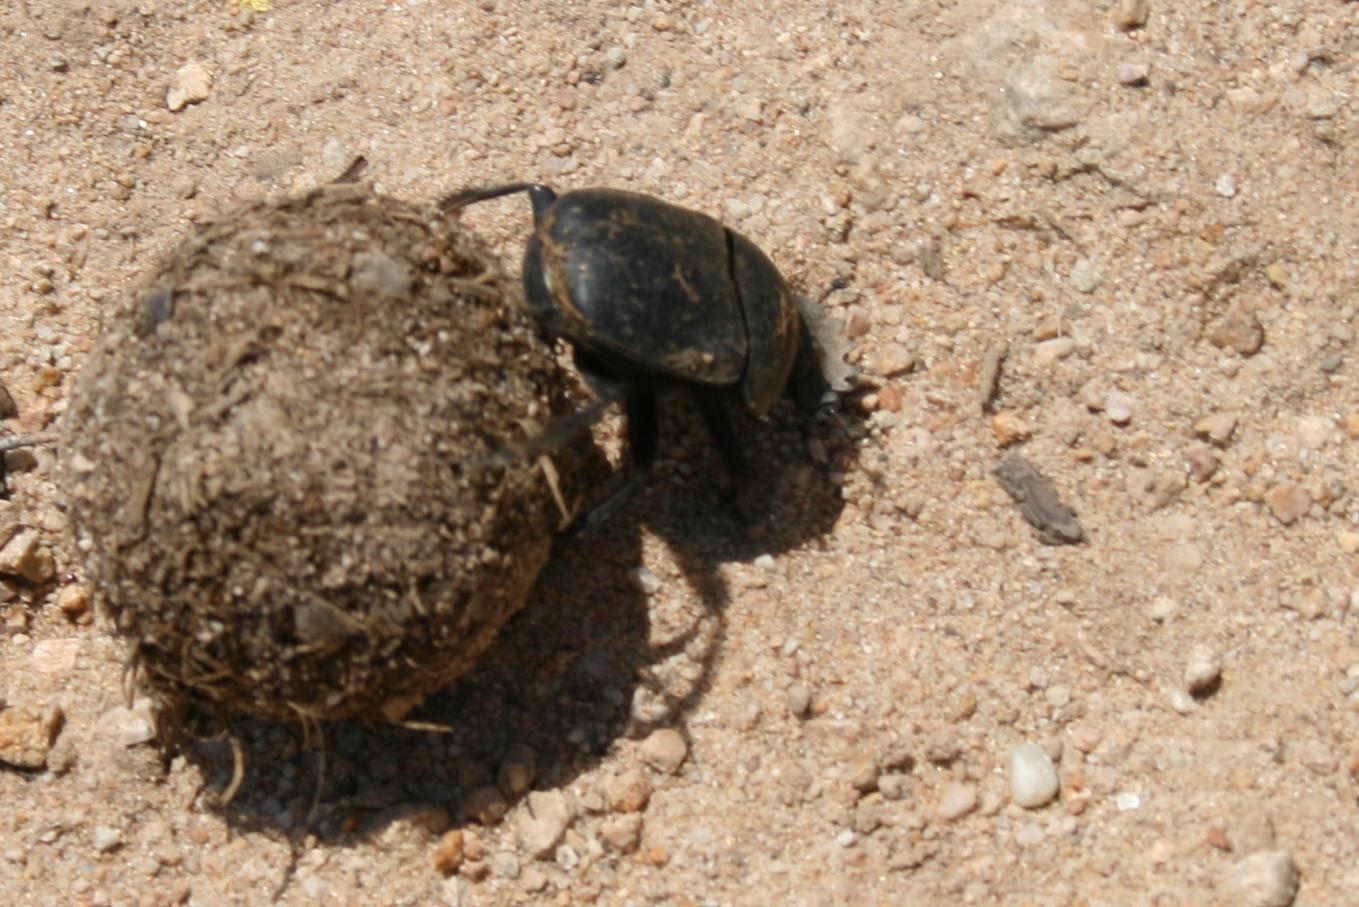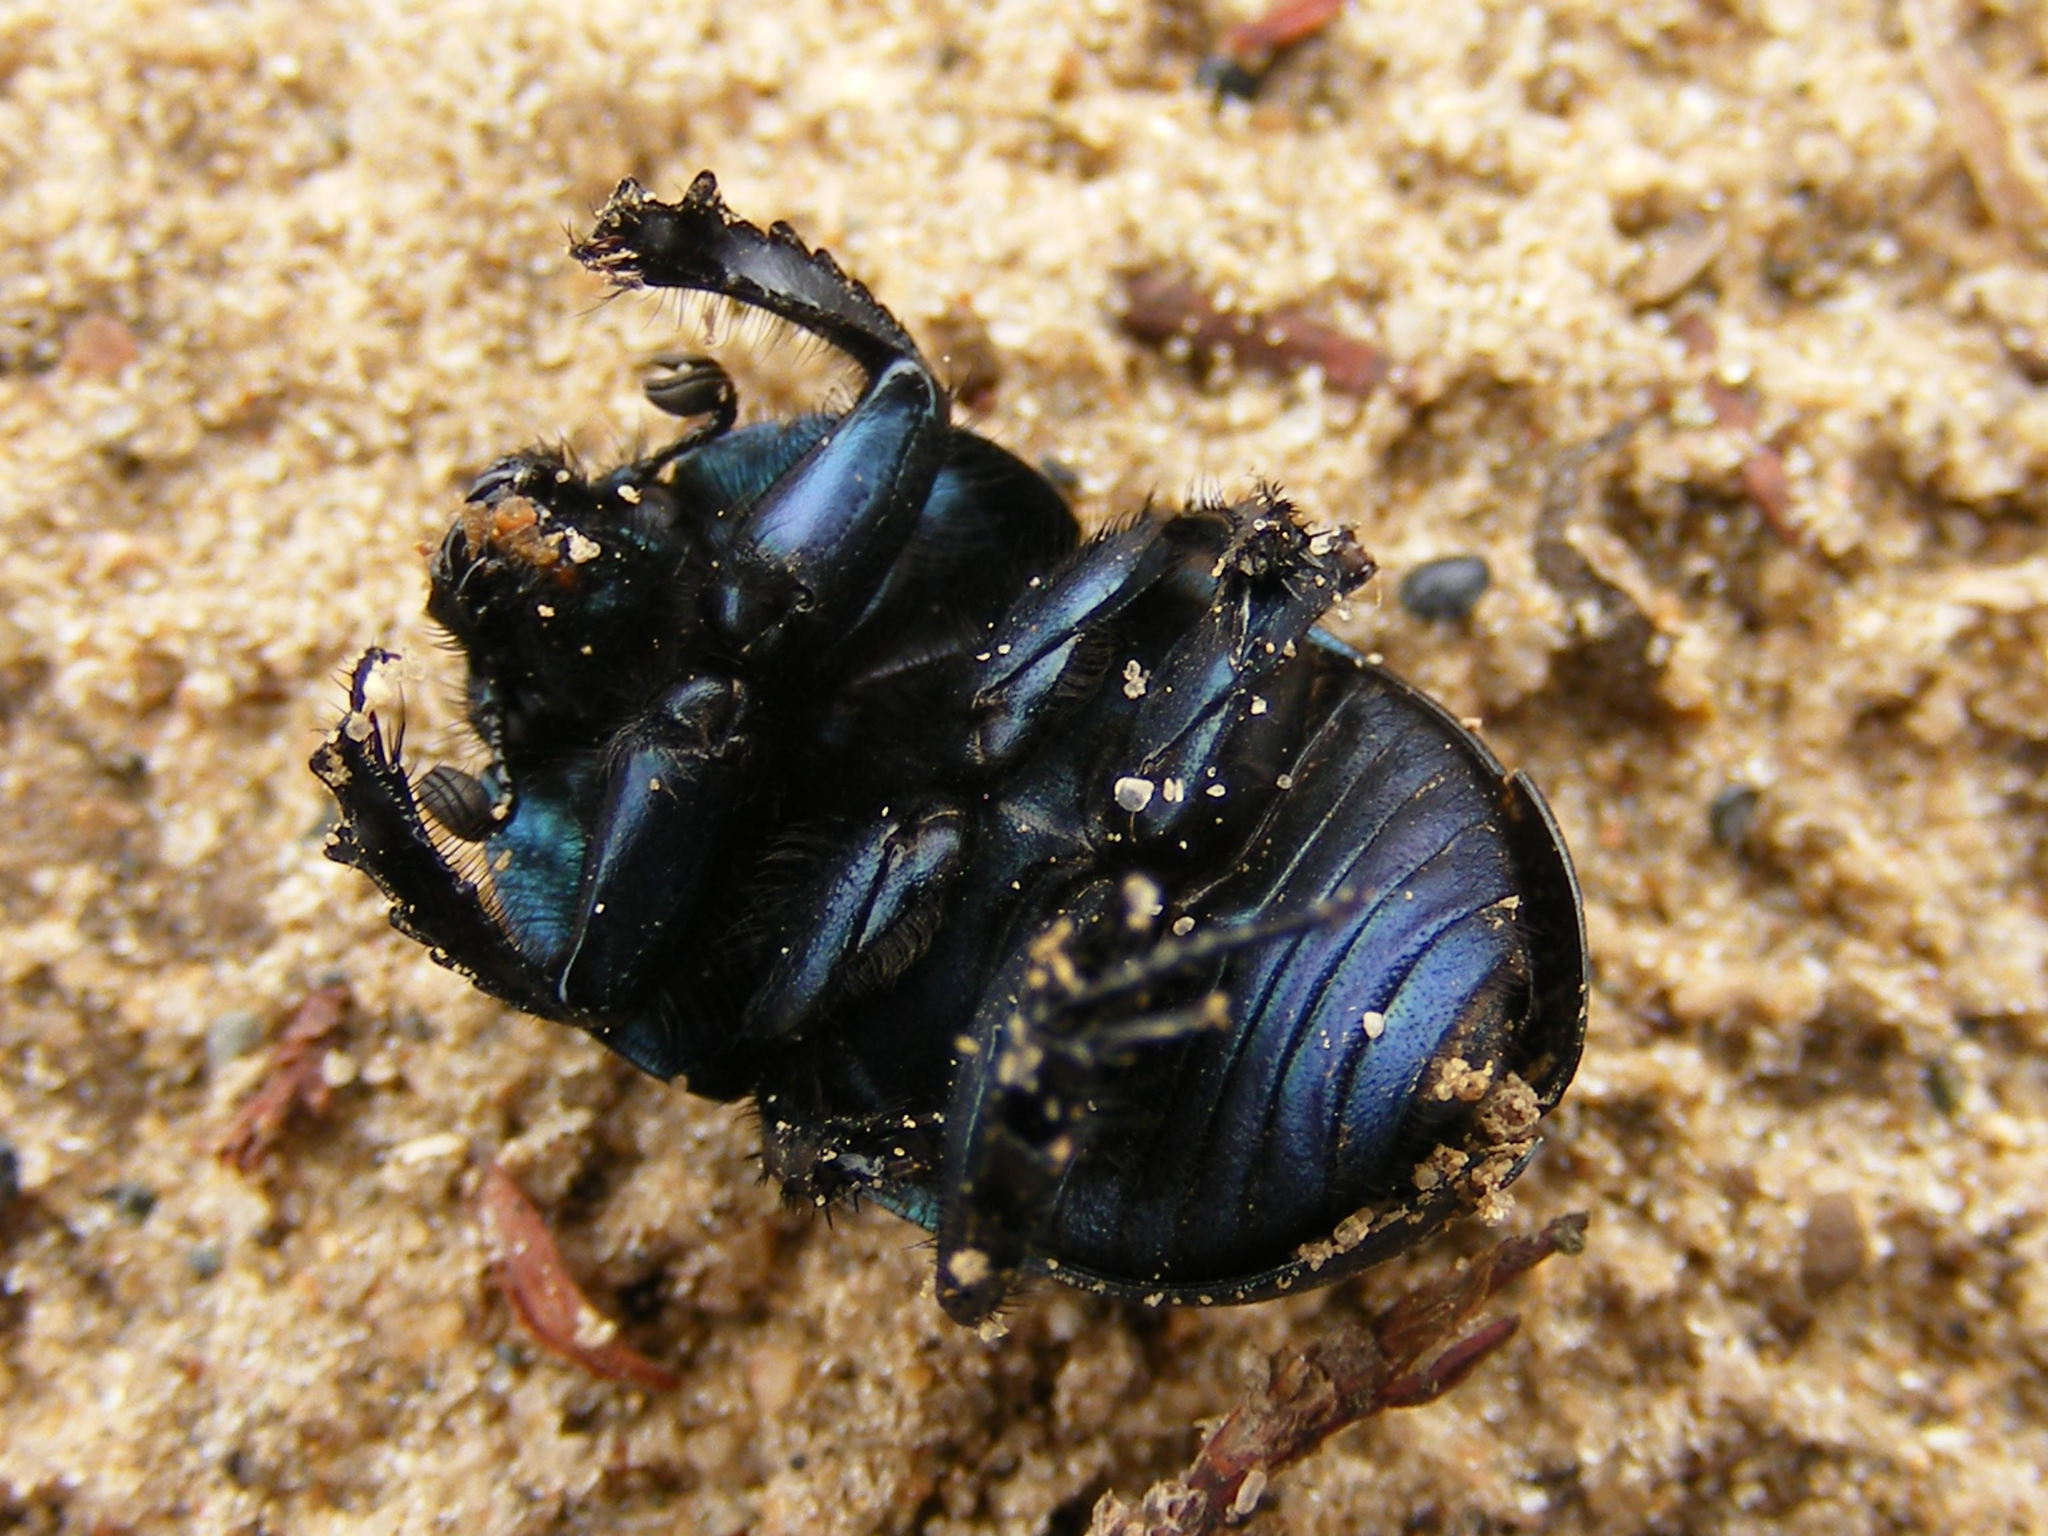The first image is the image on the left, the second image is the image on the right. Considering the images on both sides, is "There are multiple beetles near the dung in one of the images." valid? Answer yes or no. No. The first image is the image on the left, the second image is the image on the right. Considering the images on both sides, is "Each image includes at least one brown ball and one beetle in contact with it, but no image contains more than two beetles." valid? Answer yes or no. No. 